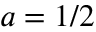Convert formula to latex. <formula><loc_0><loc_0><loc_500><loc_500>a = 1 / 2</formula> 